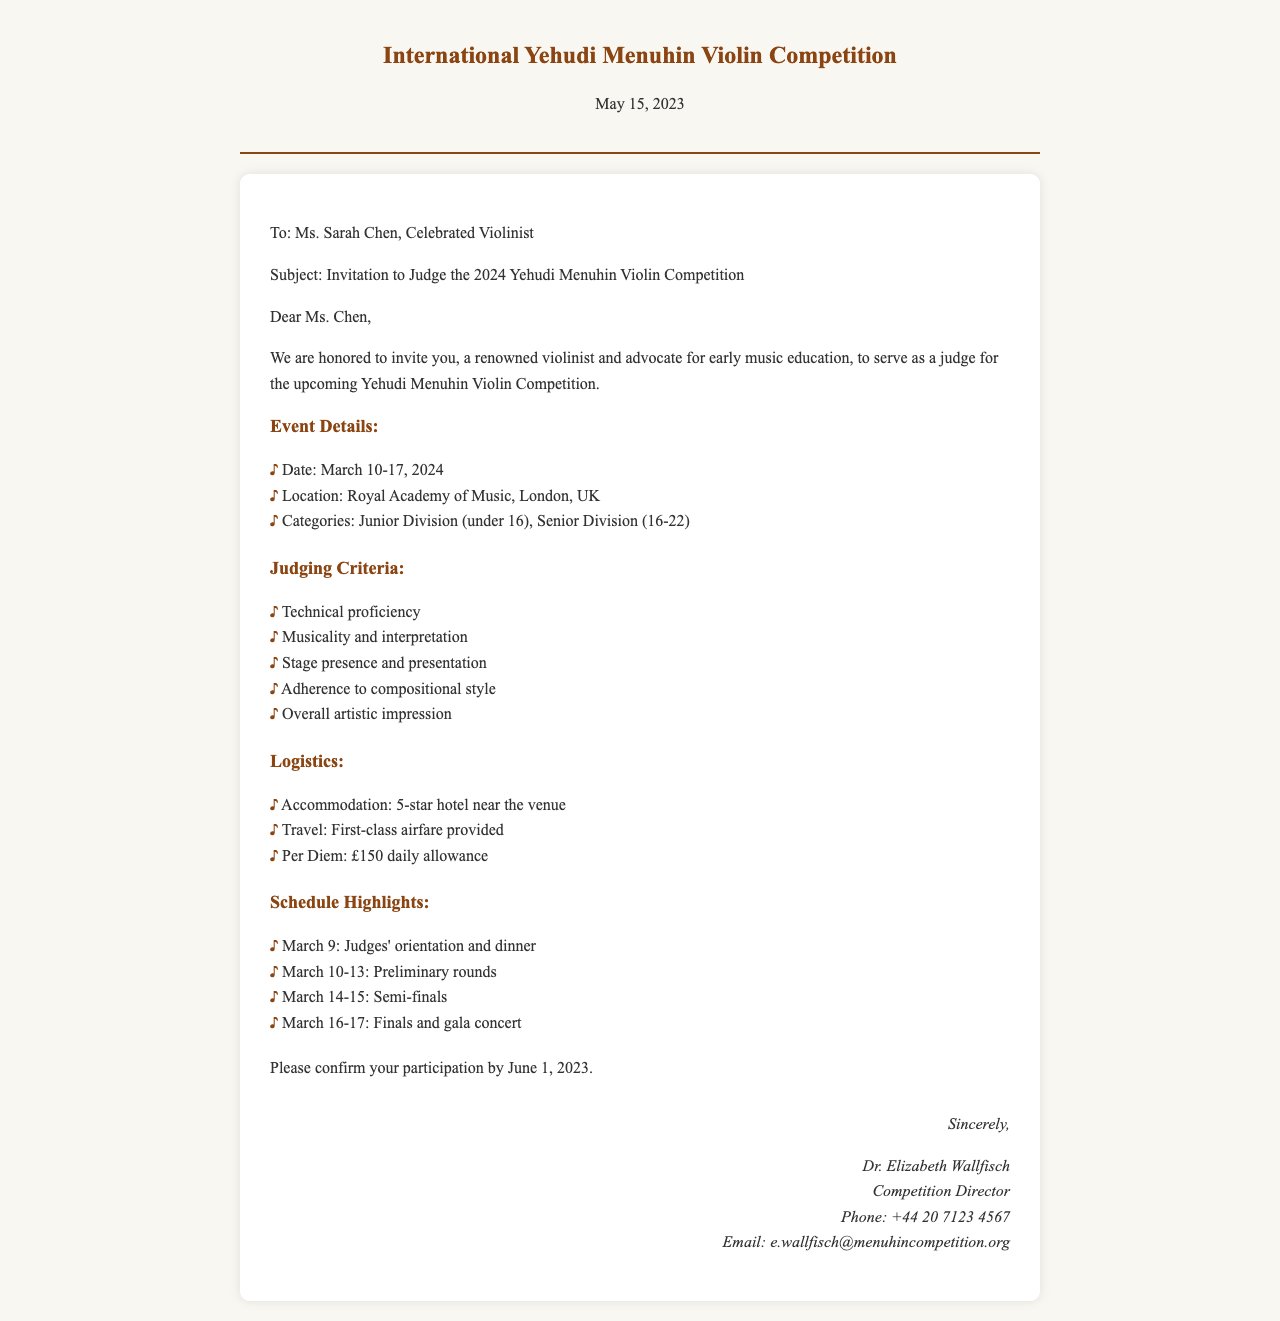What is the date of the event? The event is taking place from March 10-17, 2024, as mentioned in the Event Details section.
Answer: March 10-17, 2024 What is the location of the competition? The document specifies that the competition will be held at the Royal Academy of Music, London, UK.
Answer: Royal Academy of Music, London, UK Who is the sender of the document? The sender is Dr. Elizabeth Wallfisch, as stated in the signature section.
Answer: Dr. Elizabeth Wallfisch What are the categories of the competition? The categories listed are Junior Division (under 16) and Senior Division (16-22).
Answer: Junior Division, Senior Division How much is the daily allowance? The document indicates a per diem of £150 for daily expenses.
Answer: £150 What is one criterion for judging? The criteria for judging include technical proficiency, which is one option provided in the Judging Criteria section.
Answer: Technical proficiency How do you confirm participation? Participants are instructed to confirm their participation by June 1, 2023.
Answer: By June 1, 2023 What happens on March 9? The document states that there will be judges' orientation and dinner on March 9.
Answer: Judges' orientation and dinner What travel arrangements are mentioned? The document mentions that first-class airfare will be provided for the judges.
Answer: First-class airfare provided 